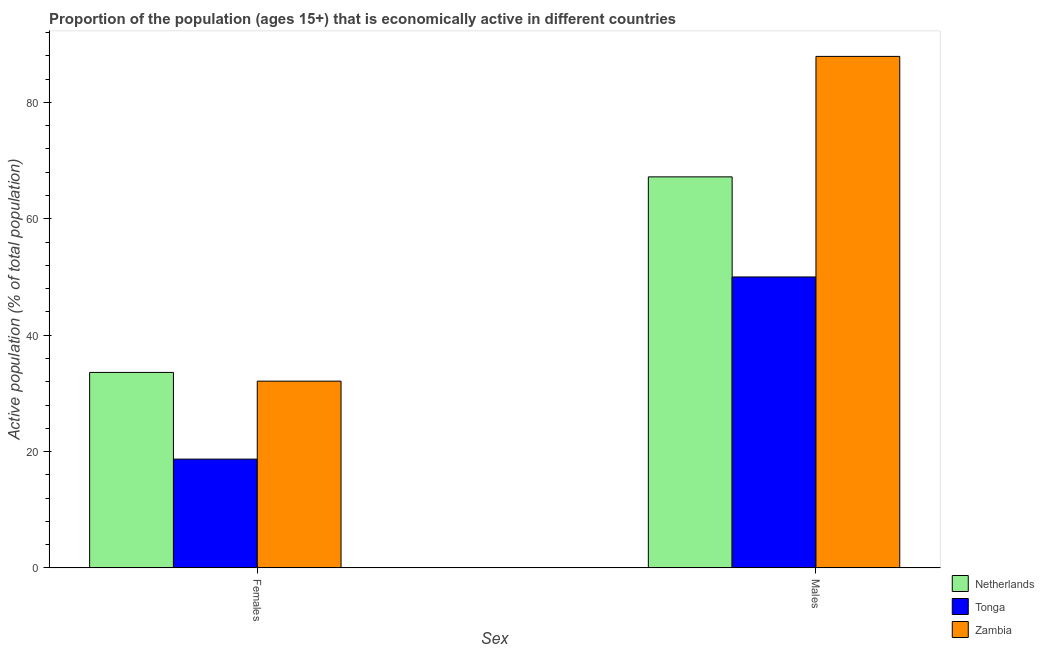How many different coloured bars are there?
Provide a short and direct response. 3. How many bars are there on the 1st tick from the left?
Give a very brief answer. 3. What is the label of the 1st group of bars from the left?
Provide a succinct answer. Females. What is the percentage of economically active male population in Netherlands?
Your answer should be very brief. 67.2. Across all countries, what is the maximum percentage of economically active female population?
Keep it short and to the point. 33.6. Across all countries, what is the minimum percentage of economically active female population?
Keep it short and to the point. 18.7. In which country was the percentage of economically active female population minimum?
Provide a succinct answer. Tonga. What is the total percentage of economically active male population in the graph?
Provide a short and direct response. 205.1. What is the difference between the percentage of economically active female population in Tonga and that in Zambia?
Provide a succinct answer. -13.4. What is the difference between the percentage of economically active male population in Zambia and the percentage of economically active female population in Netherlands?
Your answer should be compact. 54.3. What is the average percentage of economically active male population per country?
Your answer should be compact. 68.37. What is the difference between the percentage of economically active male population and percentage of economically active female population in Zambia?
Your response must be concise. 55.8. What is the ratio of the percentage of economically active female population in Netherlands to that in Zambia?
Give a very brief answer. 1.05. In how many countries, is the percentage of economically active female population greater than the average percentage of economically active female population taken over all countries?
Offer a very short reply. 2. What does the 1st bar from the left in Males represents?
Keep it short and to the point. Netherlands. What does the 2nd bar from the right in Females represents?
Your answer should be very brief. Tonga. How many bars are there?
Ensure brevity in your answer.  6. What is the difference between two consecutive major ticks on the Y-axis?
Your answer should be compact. 20. Does the graph contain any zero values?
Your answer should be compact. No. Does the graph contain grids?
Ensure brevity in your answer.  No. Where does the legend appear in the graph?
Keep it short and to the point. Bottom right. What is the title of the graph?
Offer a terse response. Proportion of the population (ages 15+) that is economically active in different countries. What is the label or title of the X-axis?
Offer a very short reply. Sex. What is the label or title of the Y-axis?
Give a very brief answer. Active population (% of total population). What is the Active population (% of total population) in Netherlands in Females?
Offer a terse response. 33.6. What is the Active population (% of total population) of Tonga in Females?
Give a very brief answer. 18.7. What is the Active population (% of total population) of Zambia in Females?
Give a very brief answer. 32.1. What is the Active population (% of total population) in Netherlands in Males?
Your answer should be compact. 67.2. What is the Active population (% of total population) in Zambia in Males?
Provide a short and direct response. 87.9. Across all Sex, what is the maximum Active population (% of total population) in Netherlands?
Provide a short and direct response. 67.2. Across all Sex, what is the maximum Active population (% of total population) of Zambia?
Offer a terse response. 87.9. Across all Sex, what is the minimum Active population (% of total population) in Netherlands?
Provide a short and direct response. 33.6. Across all Sex, what is the minimum Active population (% of total population) in Tonga?
Provide a succinct answer. 18.7. Across all Sex, what is the minimum Active population (% of total population) of Zambia?
Your answer should be compact. 32.1. What is the total Active population (% of total population) in Netherlands in the graph?
Your answer should be compact. 100.8. What is the total Active population (% of total population) in Tonga in the graph?
Your answer should be very brief. 68.7. What is the total Active population (% of total population) of Zambia in the graph?
Offer a very short reply. 120. What is the difference between the Active population (% of total population) in Netherlands in Females and that in Males?
Provide a succinct answer. -33.6. What is the difference between the Active population (% of total population) in Tonga in Females and that in Males?
Your answer should be very brief. -31.3. What is the difference between the Active population (% of total population) in Zambia in Females and that in Males?
Give a very brief answer. -55.8. What is the difference between the Active population (% of total population) in Netherlands in Females and the Active population (% of total population) in Tonga in Males?
Your response must be concise. -16.4. What is the difference between the Active population (% of total population) of Netherlands in Females and the Active population (% of total population) of Zambia in Males?
Your answer should be compact. -54.3. What is the difference between the Active population (% of total population) in Tonga in Females and the Active population (% of total population) in Zambia in Males?
Provide a short and direct response. -69.2. What is the average Active population (% of total population) in Netherlands per Sex?
Offer a very short reply. 50.4. What is the average Active population (% of total population) of Tonga per Sex?
Make the answer very short. 34.35. What is the average Active population (% of total population) in Zambia per Sex?
Your answer should be compact. 60. What is the difference between the Active population (% of total population) of Netherlands and Active population (% of total population) of Tonga in Females?
Make the answer very short. 14.9. What is the difference between the Active population (% of total population) of Tonga and Active population (% of total population) of Zambia in Females?
Provide a short and direct response. -13.4. What is the difference between the Active population (% of total population) in Netherlands and Active population (% of total population) in Tonga in Males?
Provide a short and direct response. 17.2. What is the difference between the Active population (% of total population) in Netherlands and Active population (% of total population) in Zambia in Males?
Your answer should be compact. -20.7. What is the difference between the Active population (% of total population) of Tonga and Active population (% of total population) of Zambia in Males?
Give a very brief answer. -37.9. What is the ratio of the Active population (% of total population) in Tonga in Females to that in Males?
Offer a terse response. 0.37. What is the ratio of the Active population (% of total population) of Zambia in Females to that in Males?
Offer a terse response. 0.37. What is the difference between the highest and the second highest Active population (% of total population) of Netherlands?
Your answer should be very brief. 33.6. What is the difference between the highest and the second highest Active population (% of total population) in Tonga?
Make the answer very short. 31.3. What is the difference between the highest and the second highest Active population (% of total population) of Zambia?
Your answer should be compact. 55.8. What is the difference between the highest and the lowest Active population (% of total population) in Netherlands?
Your answer should be compact. 33.6. What is the difference between the highest and the lowest Active population (% of total population) in Tonga?
Your response must be concise. 31.3. What is the difference between the highest and the lowest Active population (% of total population) in Zambia?
Your response must be concise. 55.8. 